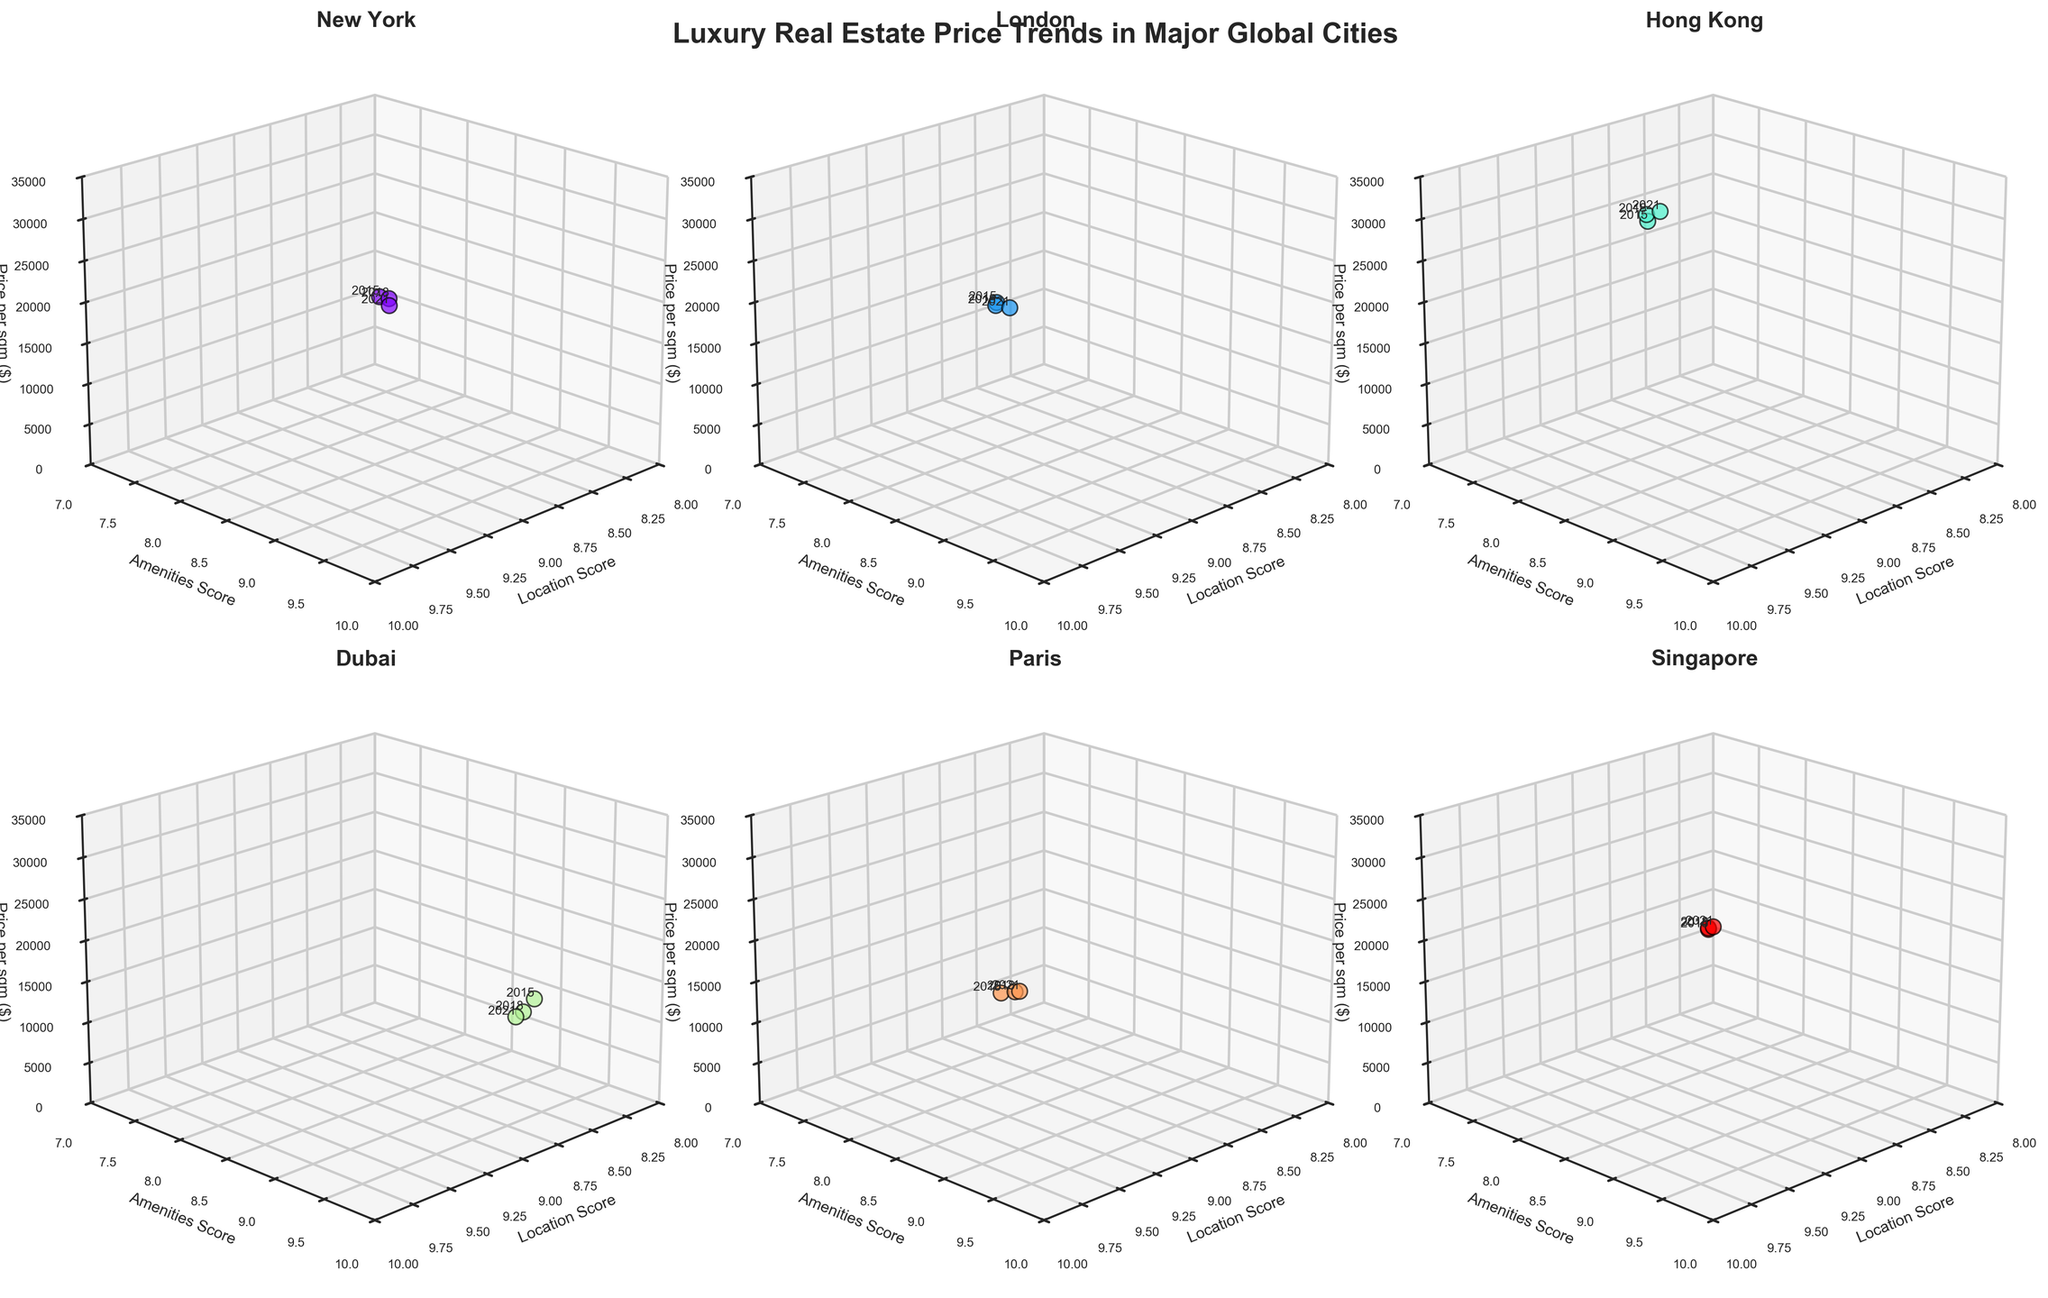How many cities are analyzed in this figure? The figure has six subplots, and each subplot corresponds to a different city. Therefore, there are six cities analyzed in the figure.
Answer: Six What are the labels on the axes? For each subplot, the x-axis is labeled "Location Score," the y-axis is labeled "Amenities Score," and the z-axis is labeled "Price per sqm ($)." This is consistent across all subplots.
Answer: Location Score, Amenities Score, Price per sqm ($) Which city shows the highest price per sqm? The subplot for Hong Kong shows the highest price per sqm, reaching up to $30,000 in 2021.
Answer: Hong Kong How does the price per sqm in New York change over time? In the New York subplot, the price per sqm increases from $15,000 in 2015 to $17,500 in 2018 and $19,000 in 2021. This visually represents a steady increase over time.
Answer: Increases Compare the Location Score for Paris and Dubai in 2021. Which one is higher? For 2021, the subplot for Paris shows a Location Score of 9.3, whereas the subplot for Dubai shows a Location Score of 8.7. Therefore, Paris has a higher Location Score in 2021.
Answer: Paris What’s the combined total price per sqm for 2015 across all cities? Summing up the prices per sqm for 2015: New York ($15,000) + London ($18,000) + Hong Kong ($25,000) + Dubai ($10,000) + Paris ($13,000) + Singapore ($20,000) = $101,000.
Answer: $101,000 How has the Amenities Score for Singapore evolved over time? In Singapore's subplot, the Amenities Score increases from 8.3 in 2015 to 8.6 in 2018 and then to 8.8 in 2021, indicating a gradual increase.
Answer: Gradual increase Is there any city where the price per sqm decreased over time? By analyzing the subplots, it is clear that no city shows a decline in the price per sqm; all cities show an increasing trend over the given years.
Answer: No Which city has the largest increase in price per sqm from 2015 to 2021? The largest increase is in Hong Kong, where the price per sqm rises from $25,000 in 2015 to $30,000 in 2021, an increase of $5,000.
Answer: Hong Kong What are the title and subtitle of the figure? The title is "Luxury Real Estate Price Trends in Major Global Cities" and there is no specific subtitle in this representation.
Answer: Luxury Real Estate Price Trends in Major Global Cities 